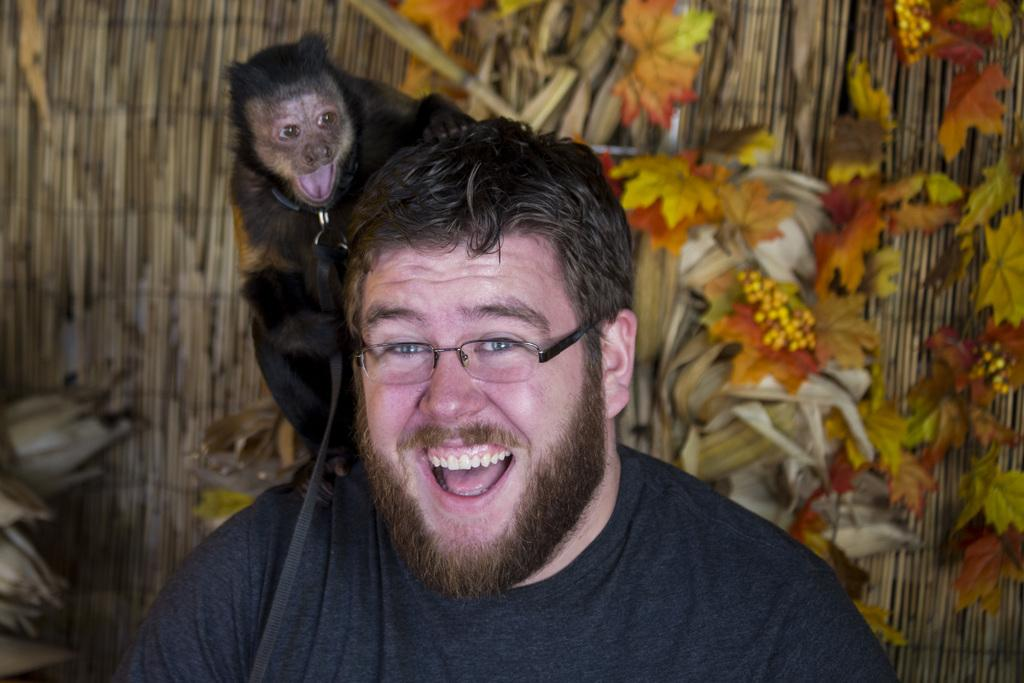What type of animal is in the image? There is a black animal in the image. What is the animal doing in the image? The animal is sitting on a man's neck. How is the man feeling in the image? The man is smiling. What type of bird is sitting on the man's neck? There is no bird present in the image. The animal in the image is a black animal, and it is not a bird. 